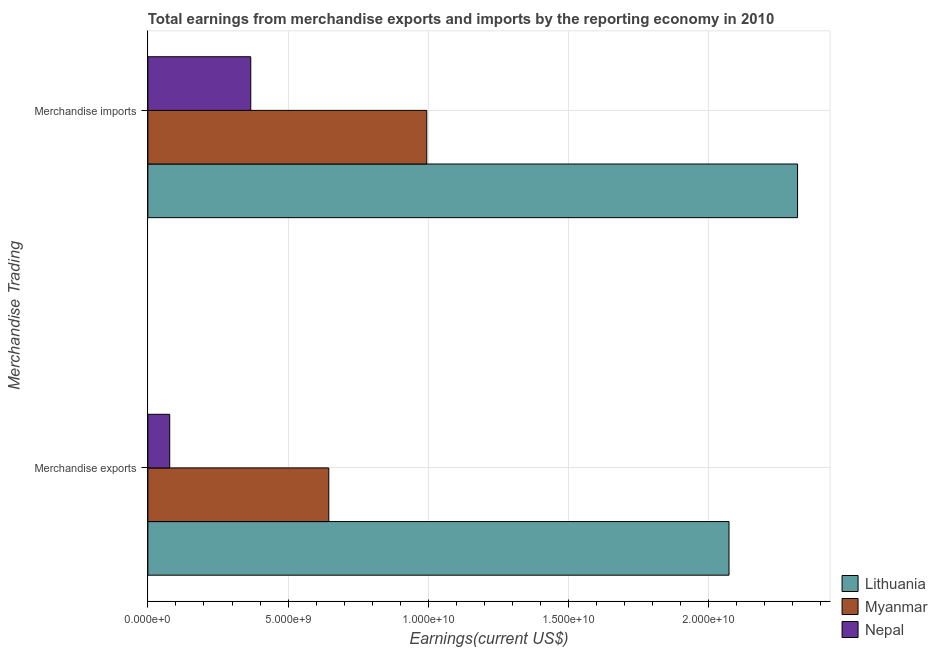How many different coloured bars are there?
Ensure brevity in your answer.  3. Are the number of bars on each tick of the Y-axis equal?
Offer a very short reply. Yes. How many bars are there on the 1st tick from the top?
Offer a very short reply. 3. How many bars are there on the 1st tick from the bottom?
Your answer should be compact. 3. What is the label of the 2nd group of bars from the top?
Your response must be concise. Merchandise exports. What is the earnings from merchandise imports in Myanmar?
Provide a succinct answer. 9.94e+09. Across all countries, what is the maximum earnings from merchandise exports?
Keep it short and to the point. 2.07e+1. Across all countries, what is the minimum earnings from merchandise exports?
Provide a succinct answer. 7.79e+08. In which country was the earnings from merchandise exports maximum?
Your answer should be very brief. Lithuania. In which country was the earnings from merchandise exports minimum?
Offer a very short reply. Nepal. What is the total earnings from merchandise imports in the graph?
Make the answer very short. 3.68e+1. What is the difference between the earnings from merchandise imports in Lithuania and that in Myanmar?
Your response must be concise. 1.32e+1. What is the difference between the earnings from merchandise imports in Myanmar and the earnings from merchandise exports in Nepal?
Provide a short and direct response. 9.17e+09. What is the average earnings from merchandise exports per country?
Provide a succinct answer. 9.32e+09. What is the difference between the earnings from merchandise exports and earnings from merchandise imports in Lithuania?
Ensure brevity in your answer.  -2.44e+09. What is the ratio of the earnings from merchandise imports in Myanmar to that in Nepal?
Your answer should be compact. 2.71. Is the earnings from merchandise exports in Myanmar less than that in Lithuania?
Make the answer very short. Yes. In how many countries, is the earnings from merchandise imports greater than the average earnings from merchandise imports taken over all countries?
Your answer should be very brief. 1. What does the 1st bar from the top in Merchandise exports represents?
Keep it short and to the point. Nepal. What does the 1st bar from the bottom in Merchandise exports represents?
Your response must be concise. Lithuania. How many countries are there in the graph?
Offer a very short reply. 3. What is the difference between two consecutive major ticks on the X-axis?
Your answer should be very brief. 5.00e+09. Are the values on the major ticks of X-axis written in scientific E-notation?
Offer a very short reply. Yes. Does the graph contain any zero values?
Make the answer very short. No. How many legend labels are there?
Offer a terse response. 3. How are the legend labels stacked?
Keep it short and to the point. Vertical. What is the title of the graph?
Ensure brevity in your answer.  Total earnings from merchandise exports and imports by the reporting economy in 2010. Does "Kazakhstan" appear as one of the legend labels in the graph?
Offer a very short reply. No. What is the label or title of the X-axis?
Offer a terse response. Earnings(current US$). What is the label or title of the Y-axis?
Provide a succinct answer. Merchandise Trading. What is the Earnings(current US$) in Lithuania in Merchandise exports?
Keep it short and to the point. 2.07e+1. What is the Earnings(current US$) of Myanmar in Merchandise exports?
Ensure brevity in your answer.  6.45e+09. What is the Earnings(current US$) in Nepal in Merchandise exports?
Make the answer very short. 7.79e+08. What is the Earnings(current US$) in Lithuania in Merchandise imports?
Make the answer very short. 2.32e+1. What is the Earnings(current US$) of Myanmar in Merchandise imports?
Your answer should be very brief. 9.94e+09. What is the Earnings(current US$) of Nepal in Merchandise imports?
Give a very brief answer. 3.67e+09. Across all Merchandise Trading, what is the maximum Earnings(current US$) in Lithuania?
Your answer should be compact. 2.32e+1. Across all Merchandise Trading, what is the maximum Earnings(current US$) of Myanmar?
Your response must be concise. 9.94e+09. Across all Merchandise Trading, what is the maximum Earnings(current US$) of Nepal?
Offer a terse response. 3.67e+09. Across all Merchandise Trading, what is the minimum Earnings(current US$) of Lithuania?
Keep it short and to the point. 2.07e+1. Across all Merchandise Trading, what is the minimum Earnings(current US$) in Myanmar?
Your answer should be very brief. 6.45e+09. Across all Merchandise Trading, what is the minimum Earnings(current US$) in Nepal?
Your answer should be very brief. 7.79e+08. What is the total Earnings(current US$) of Lithuania in the graph?
Offer a terse response. 4.39e+1. What is the total Earnings(current US$) in Myanmar in the graph?
Your answer should be compact. 1.64e+1. What is the total Earnings(current US$) in Nepal in the graph?
Give a very brief answer. 4.45e+09. What is the difference between the Earnings(current US$) of Lithuania in Merchandise exports and that in Merchandise imports?
Provide a short and direct response. -2.44e+09. What is the difference between the Earnings(current US$) of Myanmar in Merchandise exports and that in Merchandise imports?
Give a very brief answer. -3.49e+09. What is the difference between the Earnings(current US$) in Nepal in Merchandise exports and that in Merchandise imports?
Offer a terse response. -2.89e+09. What is the difference between the Earnings(current US$) of Lithuania in Merchandise exports and the Earnings(current US$) of Myanmar in Merchandise imports?
Ensure brevity in your answer.  1.08e+1. What is the difference between the Earnings(current US$) in Lithuania in Merchandise exports and the Earnings(current US$) in Nepal in Merchandise imports?
Your response must be concise. 1.71e+1. What is the difference between the Earnings(current US$) of Myanmar in Merchandise exports and the Earnings(current US$) of Nepal in Merchandise imports?
Make the answer very short. 2.78e+09. What is the average Earnings(current US$) in Lithuania per Merchandise Trading?
Provide a succinct answer. 2.19e+1. What is the average Earnings(current US$) of Myanmar per Merchandise Trading?
Offer a terse response. 8.20e+09. What is the average Earnings(current US$) in Nepal per Merchandise Trading?
Ensure brevity in your answer.  2.22e+09. What is the difference between the Earnings(current US$) of Lithuania and Earnings(current US$) of Myanmar in Merchandise exports?
Give a very brief answer. 1.43e+1. What is the difference between the Earnings(current US$) of Lithuania and Earnings(current US$) of Nepal in Merchandise exports?
Your answer should be very brief. 1.99e+1. What is the difference between the Earnings(current US$) of Myanmar and Earnings(current US$) of Nepal in Merchandise exports?
Your response must be concise. 5.67e+09. What is the difference between the Earnings(current US$) in Lithuania and Earnings(current US$) in Myanmar in Merchandise imports?
Offer a terse response. 1.32e+1. What is the difference between the Earnings(current US$) in Lithuania and Earnings(current US$) in Nepal in Merchandise imports?
Provide a short and direct response. 1.95e+1. What is the difference between the Earnings(current US$) of Myanmar and Earnings(current US$) of Nepal in Merchandise imports?
Provide a short and direct response. 6.28e+09. What is the ratio of the Earnings(current US$) in Lithuania in Merchandise exports to that in Merchandise imports?
Provide a succinct answer. 0.89. What is the ratio of the Earnings(current US$) of Myanmar in Merchandise exports to that in Merchandise imports?
Your answer should be compact. 0.65. What is the ratio of the Earnings(current US$) of Nepal in Merchandise exports to that in Merchandise imports?
Ensure brevity in your answer.  0.21. What is the difference between the highest and the second highest Earnings(current US$) of Lithuania?
Your answer should be very brief. 2.44e+09. What is the difference between the highest and the second highest Earnings(current US$) in Myanmar?
Your response must be concise. 3.49e+09. What is the difference between the highest and the second highest Earnings(current US$) in Nepal?
Make the answer very short. 2.89e+09. What is the difference between the highest and the lowest Earnings(current US$) of Lithuania?
Offer a terse response. 2.44e+09. What is the difference between the highest and the lowest Earnings(current US$) in Myanmar?
Make the answer very short. 3.49e+09. What is the difference between the highest and the lowest Earnings(current US$) in Nepal?
Offer a terse response. 2.89e+09. 